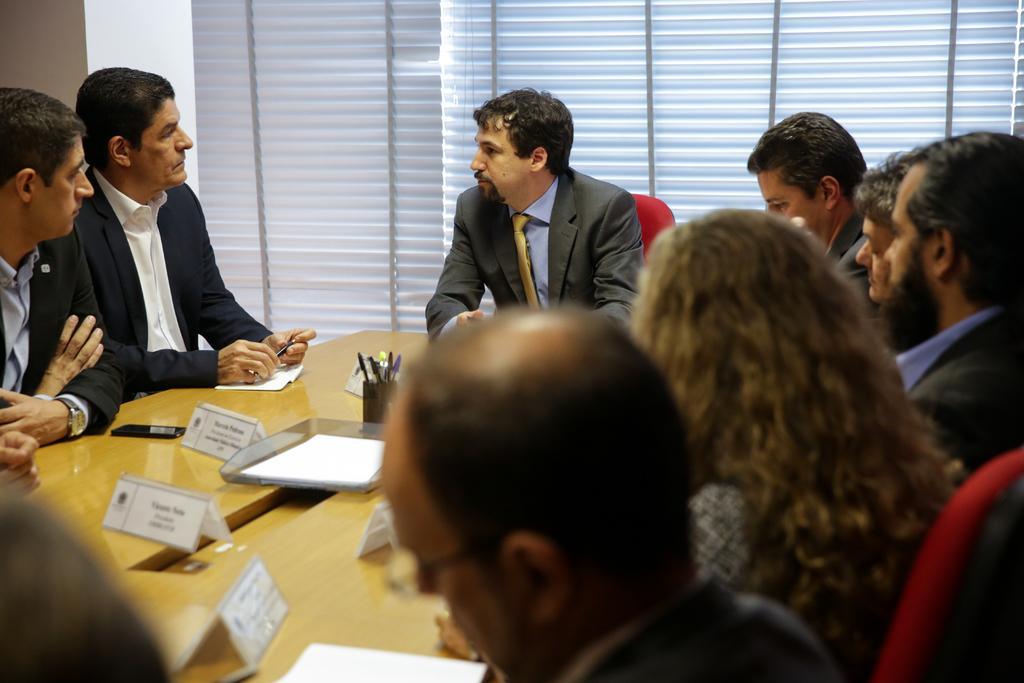How would you summarize this image in a sentence or two? In this image I can see the group of people sitting in-front of the table. I can see these people are wearing the different color dresses. On the table I can see many boards, pens holder and the mobile. In the background I can see the window blind. 